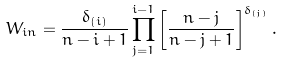Convert formula to latex. <formula><loc_0><loc_0><loc_500><loc_500>W _ { i n } = \frac { \delta _ { ( i ) } } { n - i + 1 } \prod _ { j = 1 } ^ { i - 1 } \left [ \frac { n - j } { n - j + 1 } \right ] ^ { \delta _ { ( j ) } } .</formula> 